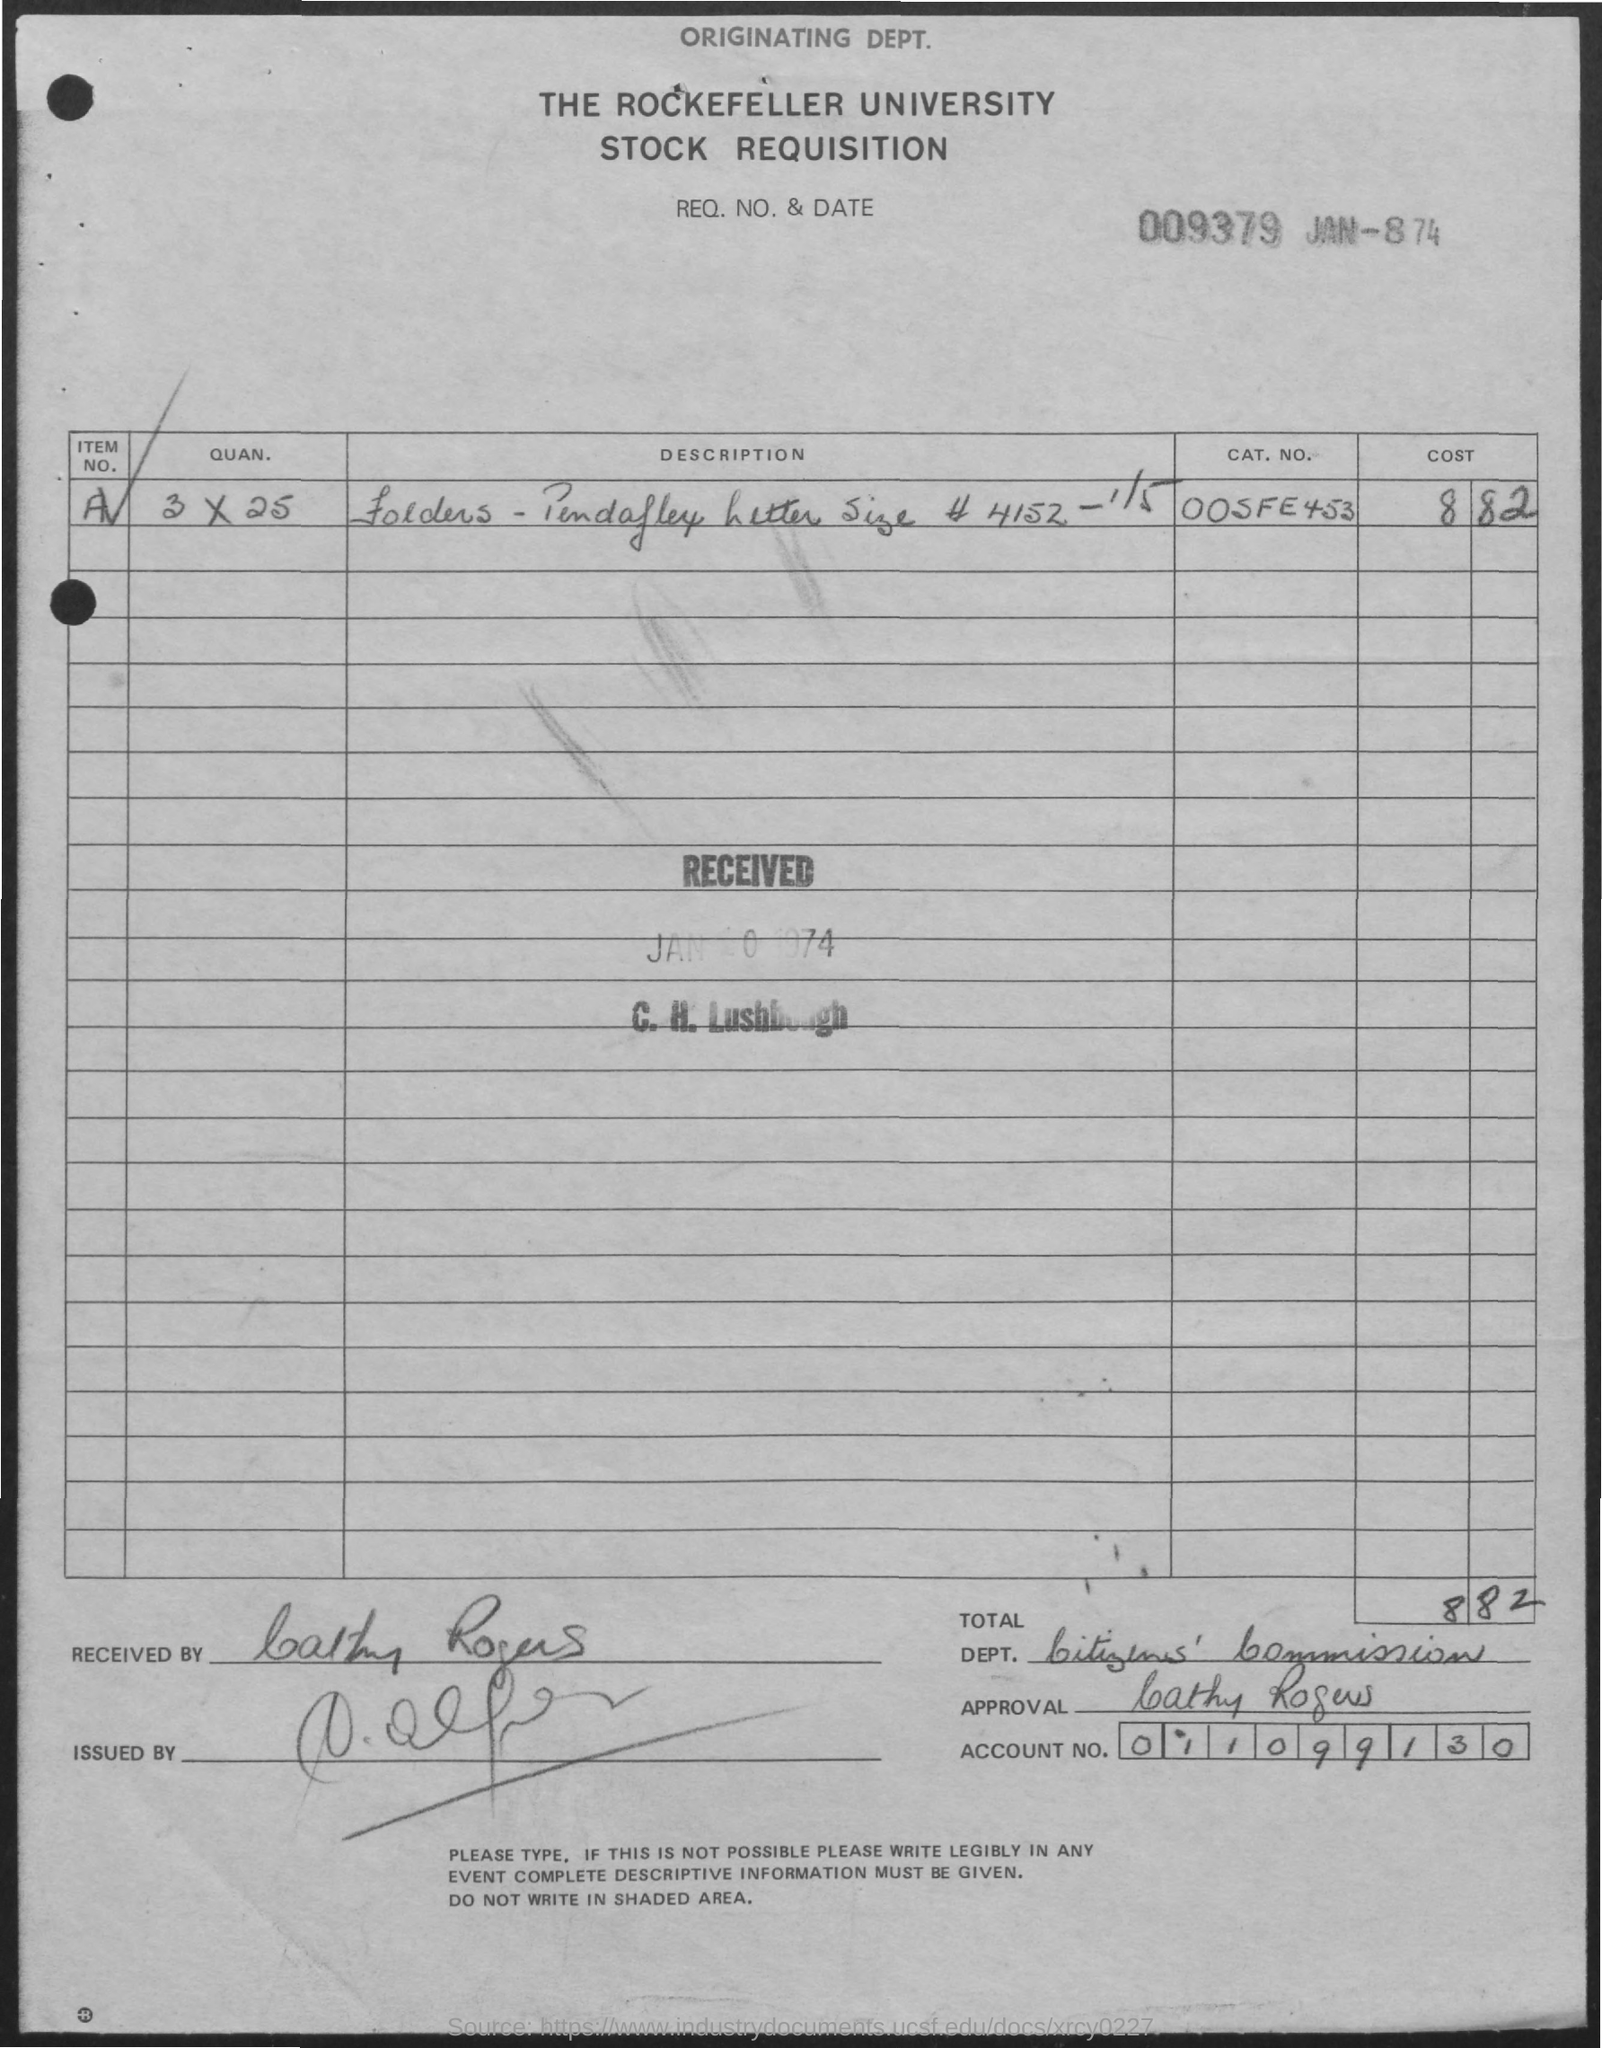What is the document title?
Your answer should be very brief. THE ROCKEFELLER UNIVERSITY STOCK REQUISITION. What is the CAT. NO.?
Your answer should be very brief. 00SFE453. What is the account number?
Ensure brevity in your answer.  011099130. 